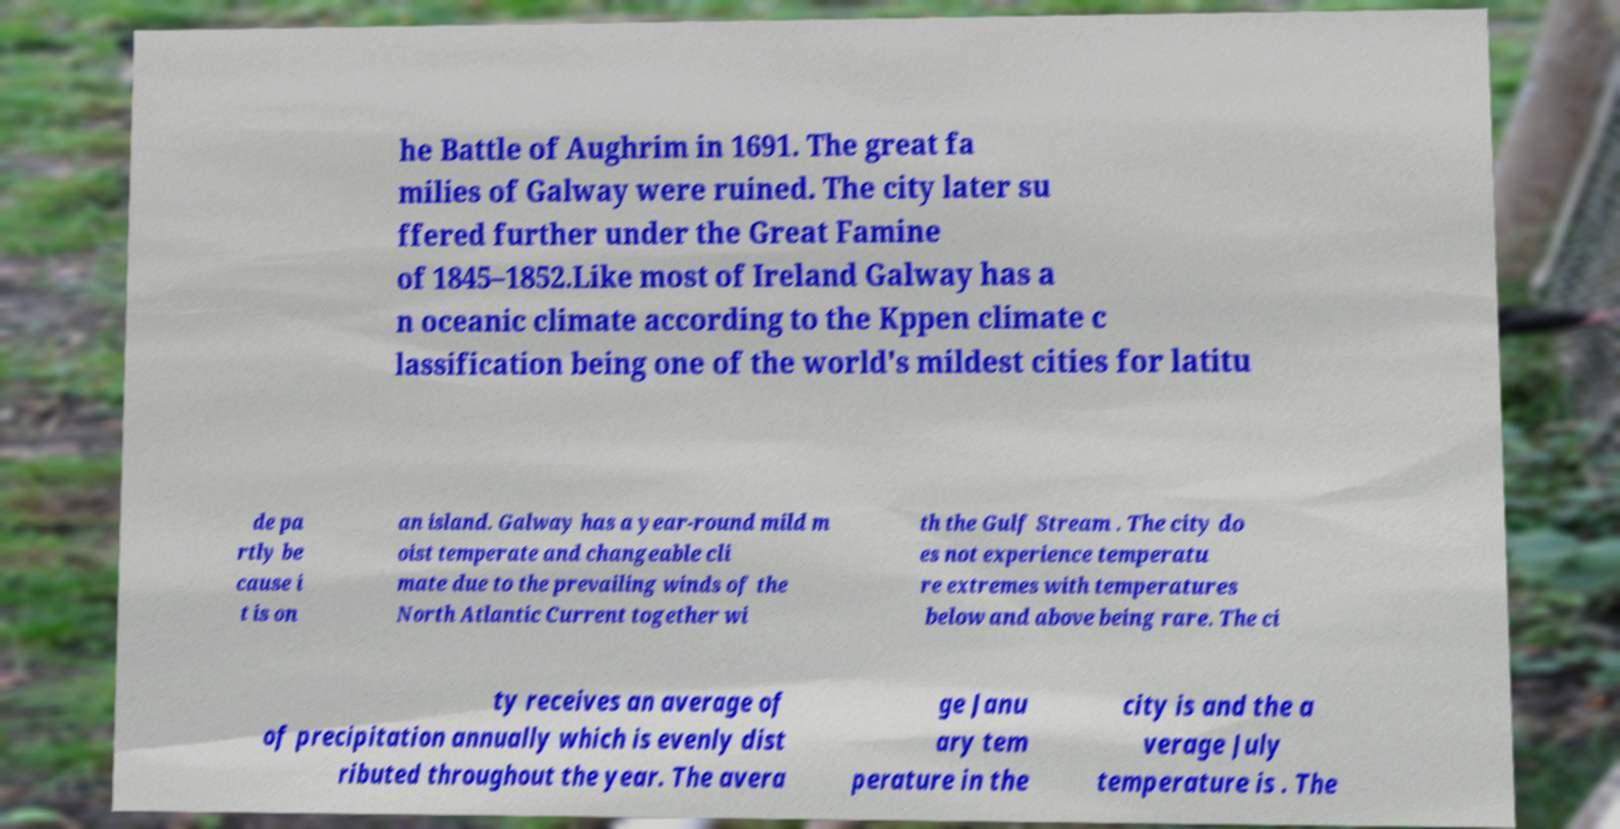Can you accurately transcribe the text from the provided image for me? he Battle of Aughrim in 1691. The great fa milies of Galway were ruined. The city later su ffered further under the Great Famine of 1845–1852.Like most of Ireland Galway has a n oceanic climate according to the Kppen climate c lassification being one of the world's mildest cities for latitu de pa rtly be cause i t is on an island. Galway has a year-round mild m oist temperate and changeable cli mate due to the prevailing winds of the North Atlantic Current together wi th the Gulf Stream . The city do es not experience temperatu re extremes with temperatures below and above being rare. The ci ty receives an average of of precipitation annually which is evenly dist ributed throughout the year. The avera ge Janu ary tem perature in the city is and the a verage July temperature is . The 